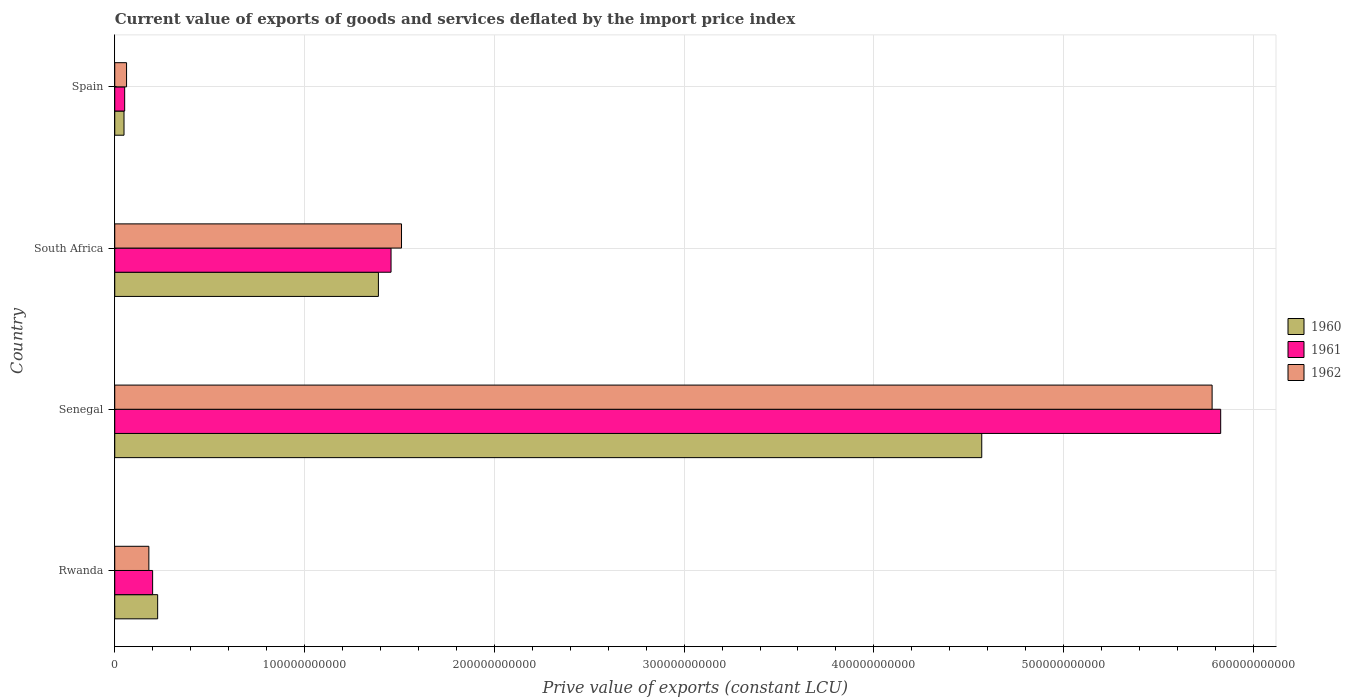How many bars are there on the 4th tick from the bottom?
Provide a short and direct response. 3. What is the label of the 3rd group of bars from the top?
Make the answer very short. Senegal. What is the prive value of exports in 1960 in South Africa?
Offer a terse response. 1.39e+11. Across all countries, what is the maximum prive value of exports in 1962?
Provide a succinct answer. 5.78e+11. Across all countries, what is the minimum prive value of exports in 1962?
Offer a terse response. 6.22e+09. In which country was the prive value of exports in 1962 maximum?
Your answer should be compact. Senegal. What is the total prive value of exports in 1960 in the graph?
Your answer should be compact. 6.23e+11. What is the difference between the prive value of exports in 1960 in South Africa and that in Spain?
Offer a very short reply. 1.34e+11. What is the difference between the prive value of exports in 1961 in Spain and the prive value of exports in 1962 in Senegal?
Provide a succinct answer. -5.73e+11. What is the average prive value of exports in 1962 per country?
Provide a short and direct response. 1.88e+11. What is the difference between the prive value of exports in 1961 and prive value of exports in 1960 in South Africa?
Make the answer very short. 6.66e+09. What is the ratio of the prive value of exports in 1961 in Senegal to that in South Africa?
Offer a very short reply. 4. Is the difference between the prive value of exports in 1961 in Rwanda and South Africa greater than the difference between the prive value of exports in 1960 in Rwanda and South Africa?
Give a very brief answer. No. What is the difference between the highest and the second highest prive value of exports in 1962?
Offer a terse response. 4.27e+11. What is the difference between the highest and the lowest prive value of exports in 1961?
Offer a very short reply. 5.77e+11. In how many countries, is the prive value of exports in 1961 greater than the average prive value of exports in 1961 taken over all countries?
Keep it short and to the point. 1. What does the 2nd bar from the top in Rwanda represents?
Give a very brief answer. 1961. Is it the case that in every country, the sum of the prive value of exports in 1961 and prive value of exports in 1960 is greater than the prive value of exports in 1962?
Ensure brevity in your answer.  Yes. How many bars are there?
Provide a succinct answer. 12. What is the difference between two consecutive major ticks on the X-axis?
Offer a very short reply. 1.00e+11. Does the graph contain any zero values?
Make the answer very short. No. Where does the legend appear in the graph?
Provide a succinct answer. Center right. How many legend labels are there?
Your answer should be compact. 3. How are the legend labels stacked?
Make the answer very short. Vertical. What is the title of the graph?
Offer a terse response. Current value of exports of goods and services deflated by the import price index. Does "1999" appear as one of the legend labels in the graph?
Make the answer very short. No. What is the label or title of the X-axis?
Provide a succinct answer. Prive value of exports (constant LCU). What is the Prive value of exports (constant LCU) of 1960 in Rwanda?
Provide a short and direct response. 2.26e+1. What is the Prive value of exports (constant LCU) in 1961 in Rwanda?
Your answer should be very brief. 2.00e+1. What is the Prive value of exports (constant LCU) in 1962 in Rwanda?
Make the answer very short. 1.80e+1. What is the Prive value of exports (constant LCU) of 1960 in Senegal?
Make the answer very short. 4.57e+11. What is the Prive value of exports (constant LCU) in 1961 in Senegal?
Make the answer very short. 5.83e+11. What is the Prive value of exports (constant LCU) in 1962 in Senegal?
Offer a very short reply. 5.78e+11. What is the Prive value of exports (constant LCU) of 1960 in South Africa?
Ensure brevity in your answer.  1.39e+11. What is the Prive value of exports (constant LCU) of 1961 in South Africa?
Your answer should be very brief. 1.46e+11. What is the Prive value of exports (constant LCU) of 1962 in South Africa?
Your response must be concise. 1.51e+11. What is the Prive value of exports (constant LCU) in 1960 in Spain?
Make the answer very short. 4.88e+09. What is the Prive value of exports (constant LCU) of 1961 in Spain?
Your answer should be compact. 5.23e+09. What is the Prive value of exports (constant LCU) of 1962 in Spain?
Your answer should be very brief. 6.22e+09. Across all countries, what is the maximum Prive value of exports (constant LCU) in 1960?
Offer a very short reply. 4.57e+11. Across all countries, what is the maximum Prive value of exports (constant LCU) in 1961?
Provide a short and direct response. 5.83e+11. Across all countries, what is the maximum Prive value of exports (constant LCU) of 1962?
Your answer should be very brief. 5.78e+11. Across all countries, what is the minimum Prive value of exports (constant LCU) of 1960?
Provide a succinct answer. 4.88e+09. Across all countries, what is the minimum Prive value of exports (constant LCU) in 1961?
Offer a very short reply. 5.23e+09. Across all countries, what is the minimum Prive value of exports (constant LCU) of 1962?
Offer a very short reply. 6.22e+09. What is the total Prive value of exports (constant LCU) of 1960 in the graph?
Your answer should be very brief. 6.23e+11. What is the total Prive value of exports (constant LCU) in 1961 in the graph?
Make the answer very short. 7.53e+11. What is the total Prive value of exports (constant LCU) in 1962 in the graph?
Ensure brevity in your answer.  7.53e+11. What is the difference between the Prive value of exports (constant LCU) of 1960 in Rwanda and that in Senegal?
Keep it short and to the point. -4.34e+11. What is the difference between the Prive value of exports (constant LCU) of 1961 in Rwanda and that in Senegal?
Your response must be concise. -5.63e+11. What is the difference between the Prive value of exports (constant LCU) in 1962 in Rwanda and that in Senegal?
Your answer should be very brief. -5.60e+11. What is the difference between the Prive value of exports (constant LCU) in 1960 in Rwanda and that in South Africa?
Offer a terse response. -1.16e+11. What is the difference between the Prive value of exports (constant LCU) of 1961 in Rwanda and that in South Africa?
Ensure brevity in your answer.  -1.26e+11. What is the difference between the Prive value of exports (constant LCU) in 1962 in Rwanda and that in South Africa?
Provide a succinct answer. -1.33e+11. What is the difference between the Prive value of exports (constant LCU) of 1960 in Rwanda and that in Spain?
Provide a succinct answer. 1.77e+1. What is the difference between the Prive value of exports (constant LCU) of 1961 in Rwanda and that in Spain?
Give a very brief answer. 1.47e+1. What is the difference between the Prive value of exports (constant LCU) of 1962 in Rwanda and that in Spain?
Your response must be concise. 1.17e+1. What is the difference between the Prive value of exports (constant LCU) of 1960 in Senegal and that in South Africa?
Keep it short and to the point. 3.18e+11. What is the difference between the Prive value of exports (constant LCU) in 1961 in Senegal and that in South Africa?
Keep it short and to the point. 4.37e+11. What is the difference between the Prive value of exports (constant LCU) in 1962 in Senegal and that in South Africa?
Offer a terse response. 4.27e+11. What is the difference between the Prive value of exports (constant LCU) in 1960 in Senegal and that in Spain?
Your response must be concise. 4.52e+11. What is the difference between the Prive value of exports (constant LCU) of 1961 in Senegal and that in Spain?
Your answer should be compact. 5.77e+11. What is the difference between the Prive value of exports (constant LCU) of 1962 in Senegal and that in Spain?
Offer a terse response. 5.72e+11. What is the difference between the Prive value of exports (constant LCU) in 1960 in South Africa and that in Spain?
Offer a terse response. 1.34e+11. What is the difference between the Prive value of exports (constant LCU) in 1961 in South Africa and that in Spain?
Offer a very short reply. 1.40e+11. What is the difference between the Prive value of exports (constant LCU) in 1962 in South Africa and that in Spain?
Provide a succinct answer. 1.45e+11. What is the difference between the Prive value of exports (constant LCU) in 1960 in Rwanda and the Prive value of exports (constant LCU) in 1961 in Senegal?
Your response must be concise. -5.60e+11. What is the difference between the Prive value of exports (constant LCU) of 1960 in Rwanda and the Prive value of exports (constant LCU) of 1962 in Senegal?
Your answer should be very brief. -5.56e+11. What is the difference between the Prive value of exports (constant LCU) of 1961 in Rwanda and the Prive value of exports (constant LCU) of 1962 in Senegal?
Make the answer very short. -5.58e+11. What is the difference between the Prive value of exports (constant LCU) of 1960 in Rwanda and the Prive value of exports (constant LCU) of 1961 in South Africa?
Give a very brief answer. -1.23e+11. What is the difference between the Prive value of exports (constant LCU) of 1960 in Rwanda and the Prive value of exports (constant LCU) of 1962 in South Africa?
Your answer should be compact. -1.28e+11. What is the difference between the Prive value of exports (constant LCU) in 1961 in Rwanda and the Prive value of exports (constant LCU) in 1962 in South Africa?
Give a very brief answer. -1.31e+11. What is the difference between the Prive value of exports (constant LCU) of 1960 in Rwanda and the Prive value of exports (constant LCU) of 1961 in Spain?
Provide a succinct answer. 1.74e+1. What is the difference between the Prive value of exports (constant LCU) in 1960 in Rwanda and the Prive value of exports (constant LCU) in 1962 in Spain?
Offer a very short reply. 1.64e+1. What is the difference between the Prive value of exports (constant LCU) in 1961 in Rwanda and the Prive value of exports (constant LCU) in 1962 in Spain?
Your answer should be compact. 1.37e+1. What is the difference between the Prive value of exports (constant LCU) of 1960 in Senegal and the Prive value of exports (constant LCU) of 1961 in South Africa?
Ensure brevity in your answer.  3.11e+11. What is the difference between the Prive value of exports (constant LCU) of 1960 in Senegal and the Prive value of exports (constant LCU) of 1962 in South Africa?
Make the answer very short. 3.06e+11. What is the difference between the Prive value of exports (constant LCU) of 1961 in Senegal and the Prive value of exports (constant LCU) of 1962 in South Africa?
Provide a short and direct response. 4.32e+11. What is the difference between the Prive value of exports (constant LCU) in 1960 in Senegal and the Prive value of exports (constant LCU) in 1961 in Spain?
Provide a succinct answer. 4.52e+11. What is the difference between the Prive value of exports (constant LCU) in 1960 in Senegal and the Prive value of exports (constant LCU) in 1962 in Spain?
Offer a very short reply. 4.51e+11. What is the difference between the Prive value of exports (constant LCU) in 1961 in Senegal and the Prive value of exports (constant LCU) in 1962 in Spain?
Offer a very short reply. 5.77e+11. What is the difference between the Prive value of exports (constant LCU) in 1960 in South Africa and the Prive value of exports (constant LCU) in 1961 in Spain?
Keep it short and to the point. 1.34e+11. What is the difference between the Prive value of exports (constant LCU) of 1960 in South Africa and the Prive value of exports (constant LCU) of 1962 in Spain?
Your response must be concise. 1.33e+11. What is the difference between the Prive value of exports (constant LCU) of 1961 in South Africa and the Prive value of exports (constant LCU) of 1962 in Spain?
Offer a terse response. 1.39e+11. What is the average Prive value of exports (constant LCU) of 1960 per country?
Your response must be concise. 1.56e+11. What is the average Prive value of exports (constant LCU) in 1961 per country?
Your response must be concise. 1.88e+11. What is the average Prive value of exports (constant LCU) of 1962 per country?
Provide a succinct answer. 1.88e+11. What is the difference between the Prive value of exports (constant LCU) of 1960 and Prive value of exports (constant LCU) of 1961 in Rwanda?
Offer a very short reply. 2.64e+09. What is the difference between the Prive value of exports (constant LCU) of 1960 and Prive value of exports (constant LCU) of 1962 in Rwanda?
Your answer should be compact. 4.63e+09. What is the difference between the Prive value of exports (constant LCU) in 1961 and Prive value of exports (constant LCU) in 1962 in Rwanda?
Offer a very short reply. 1.99e+09. What is the difference between the Prive value of exports (constant LCU) in 1960 and Prive value of exports (constant LCU) in 1961 in Senegal?
Offer a terse response. -1.26e+11. What is the difference between the Prive value of exports (constant LCU) in 1960 and Prive value of exports (constant LCU) in 1962 in Senegal?
Offer a terse response. -1.21e+11. What is the difference between the Prive value of exports (constant LCU) of 1961 and Prive value of exports (constant LCU) of 1962 in Senegal?
Keep it short and to the point. 4.52e+09. What is the difference between the Prive value of exports (constant LCU) of 1960 and Prive value of exports (constant LCU) of 1961 in South Africa?
Ensure brevity in your answer.  -6.66e+09. What is the difference between the Prive value of exports (constant LCU) in 1960 and Prive value of exports (constant LCU) in 1962 in South Africa?
Give a very brief answer. -1.22e+1. What is the difference between the Prive value of exports (constant LCU) in 1961 and Prive value of exports (constant LCU) in 1962 in South Africa?
Keep it short and to the point. -5.52e+09. What is the difference between the Prive value of exports (constant LCU) in 1960 and Prive value of exports (constant LCU) in 1961 in Spain?
Give a very brief answer. -3.48e+08. What is the difference between the Prive value of exports (constant LCU) of 1960 and Prive value of exports (constant LCU) of 1962 in Spain?
Your response must be concise. -1.34e+09. What is the difference between the Prive value of exports (constant LCU) of 1961 and Prive value of exports (constant LCU) of 1962 in Spain?
Make the answer very short. -9.94e+08. What is the ratio of the Prive value of exports (constant LCU) in 1960 in Rwanda to that in Senegal?
Ensure brevity in your answer.  0.05. What is the ratio of the Prive value of exports (constant LCU) in 1961 in Rwanda to that in Senegal?
Your answer should be very brief. 0.03. What is the ratio of the Prive value of exports (constant LCU) of 1962 in Rwanda to that in Senegal?
Ensure brevity in your answer.  0.03. What is the ratio of the Prive value of exports (constant LCU) in 1960 in Rwanda to that in South Africa?
Make the answer very short. 0.16. What is the ratio of the Prive value of exports (constant LCU) of 1961 in Rwanda to that in South Africa?
Make the answer very short. 0.14. What is the ratio of the Prive value of exports (constant LCU) in 1962 in Rwanda to that in South Africa?
Your answer should be compact. 0.12. What is the ratio of the Prive value of exports (constant LCU) of 1960 in Rwanda to that in Spain?
Your answer should be compact. 4.63. What is the ratio of the Prive value of exports (constant LCU) in 1961 in Rwanda to that in Spain?
Offer a very short reply. 3.82. What is the ratio of the Prive value of exports (constant LCU) of 1962 in Rwanda to that in Spain?
Offer a terse response. 2.89. What is the ratio of the Prive value of exports (constant LCU) of 1960 in Senegal to that in South Africa?
Your answer should be very brief. 3.29. What is the ratio of the Prive value of exports (constant LCU) in 1961 in Senegal to that in South Africa?
Provide a succinct answer. 4. What is the ratio of the Prive value of exports (constant LCU) of 1962 in Senegal to that in South Africa?
Make the answer very short. 3.83. What is the ratio of the Prive value of exports (constant LCU) in 1960 in Senegal to that in Spain?
Provide a succinct answer. 93.66. What is the ratio of the Prive value of exports (constant LCU) of 1961 in Senegal to that in Spain?
Give a very brief answer. 111.52. What is the ratio of the Prive value of exports (constant LCU) of 1962 in Senegal to that in Spain?
Give a very brief answer. 92.97. What is the ratio of the Prive value of exports (constant LCU) of 1960 in South Africa to that in Spain?
Make the answer very short. 28.48. What is the ratio of the Prive value of exports (constant LCU) in 1961 in South Africa to that in Spain?
Offer a very short reply. 27.86. What is the ratio of the Prive value of exports (constant LCU) of 1962 in South Africa to that in Spain?
Keep it short and to the point. 24.29. What is the difference between the highest and the second highest Prive value of exports (constant LCU) in 1960?
Keep it short and to the point. 3.18e+11. What is the difference between the highest and the second highest Prive value of exports (constant LCU) in 1961?
Provide a succinct answer. 4.37e+11. What is the difference between the highest and the second highest Prive value of exports (constant LCU) in 1962?
Your response must be concise. 4.27e+11. What is the difference between the highest and the lowest Prive value of exports (constant LCU) in 1960?
Your response must be concise. 4.52e+11. What is the difference between the highest and the lowest Prive value of exports (constant LCU) of 1961?
Keep it short and to the point. 5.77e+11. What is the difference between the highest and the lowest Prive value of exports (constant LCU) of 1962?
Offer a very short reply. 5.72e+11. 